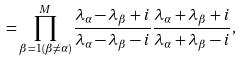<formula> <loc_0><loc_0><loc_500><loc_500>= \prod _ { \beta = 1 ( \beta \neq \alpha ) } ^ { M } \frac { \lambda _ { \alpha } - \lambda _ { \beta } + i } { \lambda _ { \alpha } - \lambda _ { \beta } - i } \frac { \lambda _ { \alpha } + \lambda _ { \beta } + i } { \lambda _ { \alpha } + \lambda _ { \beta } - i } ,</formula> 